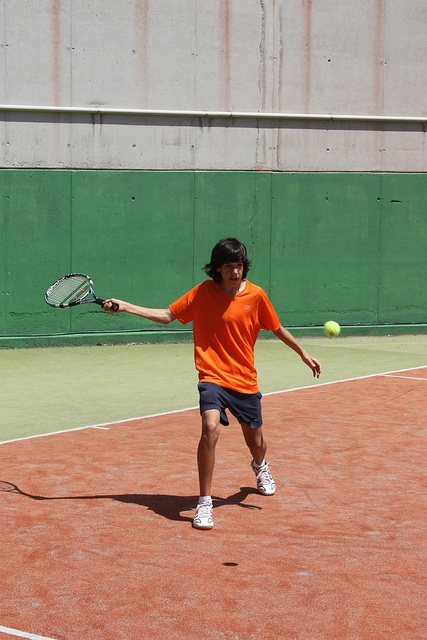Describe the objects in this image and their specific colors. I can see people in darkgray, maroon, black, and red tones, tennis racket in darkgray, gray, black, and teal tones, and sports ball in darkgray, khaki, olive, and lightgreen tones in this image. 